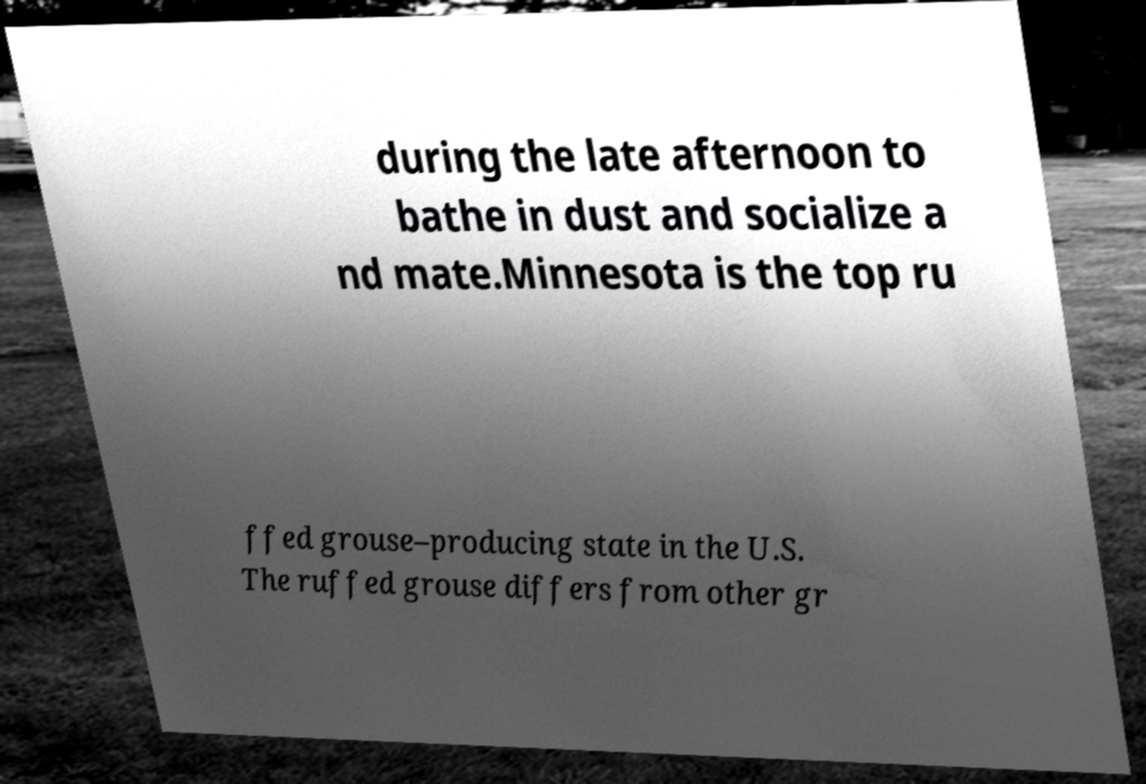There's text embedded in this image that I need extracted. Can you transcribe it verbatim? during the late afternoon to bathe in dust and socialize a nd mate.Minnesota is the top ru ffed grouse–producing state in the U.S. The ruffed grouse differs from other gr 